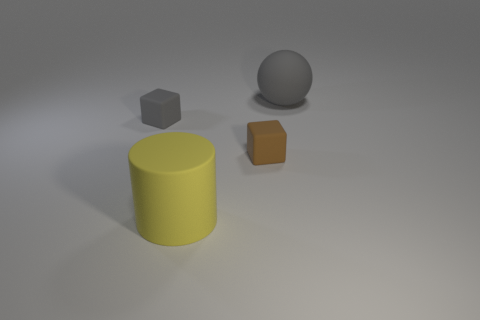How many other things are there of the same color as the rubber cylinder?
Your answer should be compact. 0. There is a gray thing that is the same size as the yellow cylinder; what is its material?
Give a very brief answer. Rubber. What number of other small things have the same material as the brown thing?
Offer a terse response. 1. There is a rubber object on the right side of the brown object; does it have the same size as the cube that is on the left side of the yellow cylinder?
Offer a very short reply. No. There is a large matte thing that is in front of the large gray rubber ball; what is its color?
Your response must be concise. Yellow. There is a thing that is the same color as the matte sphere; what is it made of?
Offer a very short reply. Rubber. How many small rubber cubes have the same color as the big cylinder?
Your answer should be very brief. 0. Do the yellow cylinder and the gray object that is left of the gray ball have the same size?
Your answer should be compact. No. There is a object that is in front of the tiny rubber object that is right of the large matte object in front of the ball; what is its size?
Provide a short and direct response. Large. How many big matte cylinders are behind the tiny brown rubber object?
Ensure brevity in your answer.  0. 